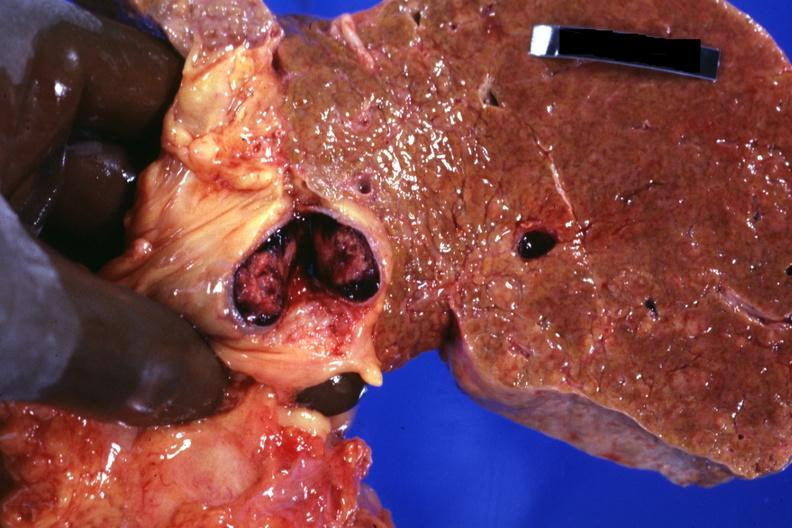what does this image show?
Answer the question using a single word or phrase. Frontal slab of liver showing cirrhosis very well that appears to be micronodular and cross sectioned portal vein with obvious thrombus very good photo 